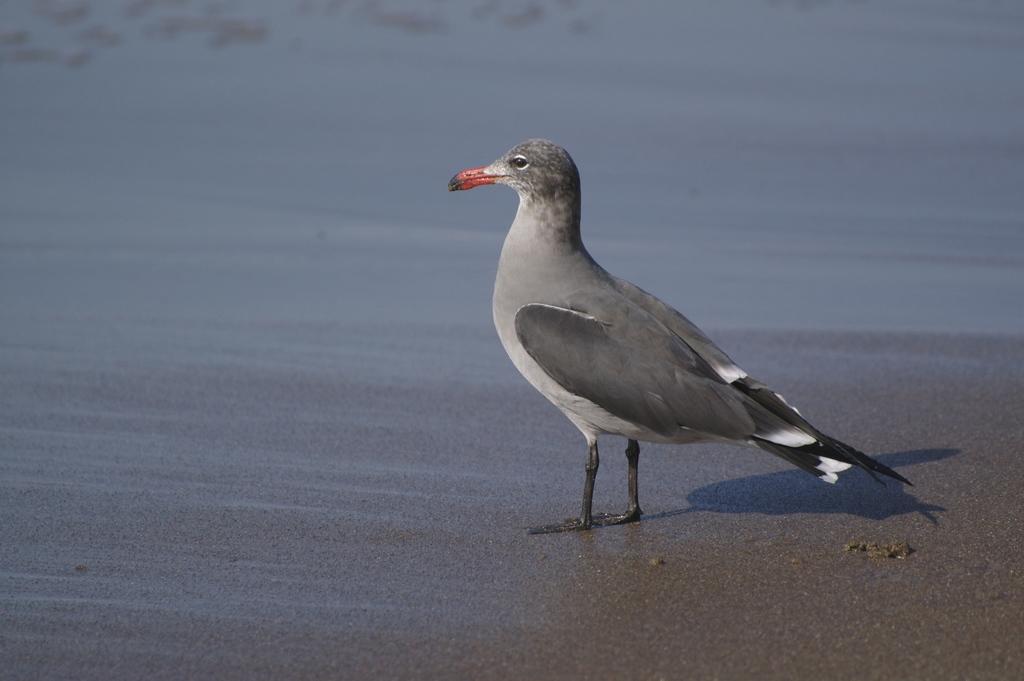In one or two sentences, can you explain what this image depicts? As we can see in the image there is a bird. 